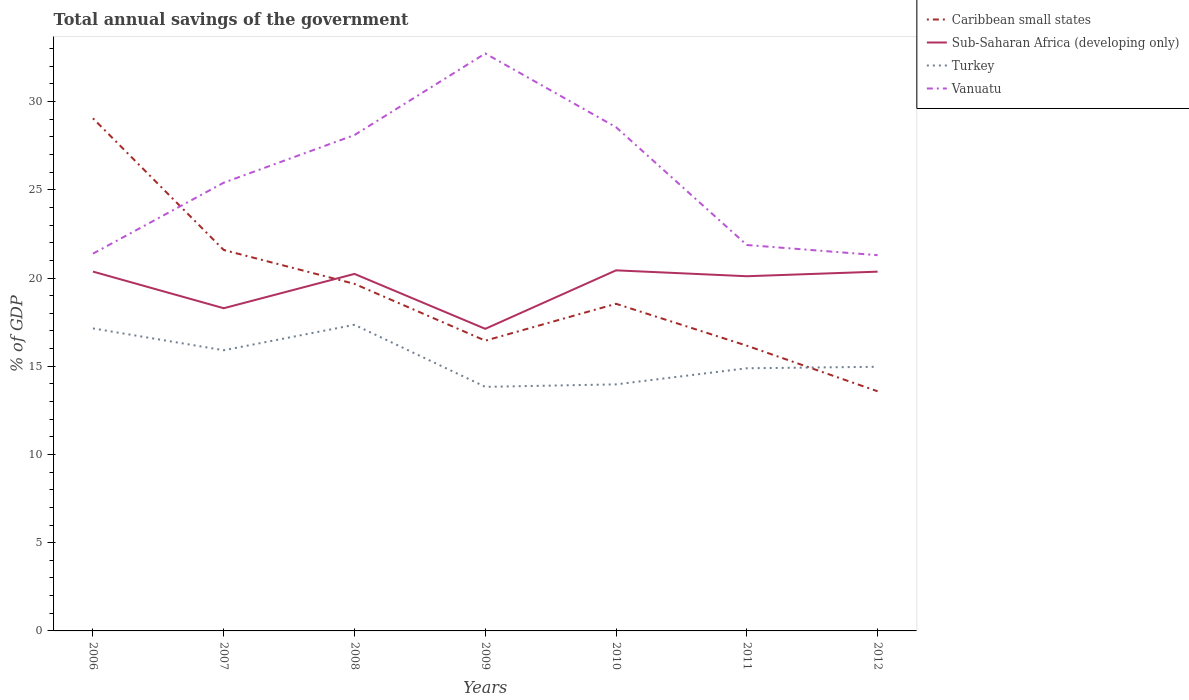How many different coloured lines are there?
Ensure brevity in your answer.  4. Across all years, what is the maximum total annual savings of the government in Sub-Saharan Africa (developing only)?
Make the answer very short. 17.12. What is the total total annual savings of the government in Caribbean small states in the graph?
Your answer should be compact. 6.09. What is the difference between the highest and the second highest total annual savings of the government in Sub-Saharan Africa (developing only)?
Provide a short and direct response. 3.31. What is the difference between the highest and the lowest total annual savings of the government in Vanuatu?
Make the answer very short. 3. Is the total annual savings of the government in Vanuatu strictly greater than the total annual savings of the government in Caribbean small states over the years?
Give a very brief answer. No. How many lines are there?
Offer a terse response. 4. How many years are there in the graph?
Give a very brief answer. 7. What is the difference between two consecutive major ticks on the Y-axis?
Keep it short and to the point. 5. How many legend labels are there?
Give a very brief answer. 4. What is the title of the graph?
Your response must be concise. Total annual savings of the government. Does "Bulgaria" appear as one of the legend labels in the graph?
Ensure brevity in your answer.  No. What is the label or title of the X-axis?
Ensure brevity in your answer.  Years. What is the label or title of the Y-axis?
Make the answer very short. % of GDP. What is the % of GDP in Caribbean small states in 2006?
Offer a very short reply. 29.05. What is the % of GDP in Sub-Saharan Africa (developing only) in 2006?
Your answer should be very brief. 20.36. What is the % of GDP of Turkey in 2006?
Your answer should be compact. 17.14. What is the % of GDP of Vanuatu in 2006?
Provide a succinct answer. 21.38. What is the % of GDP in Caribbean small states in 2007?
Provide a succinct answer. 21.59. What is the % of GDP in Sub-Saharan Africa (developing only) in 2007?
Make the answer very short. 18.29. What is the % of GDP of Turkey in 2007?
Offer a very short reply. 15.91. What is the % of GDP in Vanuatu in 2007?
Provide a short and direct response. 25.4. What is the % of GDP of Caribbean small states in 2008?
Your answer should be very brief. 19.67. What is the % of GDP of Sub-Saharan Africa (developing only) in 2008?
Your response must be concise. 20.23. What is the % of GDP in Turkey in 2008?
Offer a very short reply. 17.35. What is the % of GDP of Vanuatu in 2008?
Offer a very short reply. 28.1. What is the % of GDP of Caribbean small states in 2009?
Your answer should be compact. 16.45. What is the % of GDP in Sub-Saharan Africa (developing only) in 2009?
Your response must be concise. 17.12. What is the % of GDP in Turkey in 2009?
Offer a very short reply. 13.83. What is the % of GDP of Vanuatu in 2009?
Offer a very short reply. 32.73. What is the % of GDP of Caribbean small states in 2010?
Your answer should be compact. 18.54. What is the % of GDP of Sub-Saharan Africa (developing only) in 2010?
Provide a short and direct response. 20.44. What is the % of GDP in Turkey in 2010?
Provide a succinct answer. 13.97. What is the % of GDP of Vanuatu in 2010?
Your response must be concise. 28.55. What is the % of GDP of Caribbean small states in 2011?
Your response must be concise. 16.16. What is the % of GDP in Sub-Saharan Africa (developing only) in 2011?
Give a very brief answer. 20.1. What is the % of GDP of Turkey in 2011?
Provide a succinct answer. 14.89. What is the % of GDP of Vanuatu in 2011?
Your answer should be compact. 21.87. What is the % of GDP of Caribbean small states in 2012?
Provide a succinct answer. 13.58. What is the % of GDP in Sub-Saharan Africa (developing only) in 2012?
Make the answer very short. 20.36. What is the % of GDP in Turkey in 2012?
Your answer should be compact. 14.97. What is the % of GDP of Vanuatu in 2012?
Provide a succinct answer. 21.29. Across all years, what is the maximum % of GDP of Caribbean small states?
Your response must be concise. 29.05. Across all years, what is the maximum % of GDP of Sub-Saharan Africa (developing only)?
Your response must be concise. 20.44. Across all years, what is the maximum % of GDP in Turkey?
Your answer should be very brief. 17.35. Across all years, what is the maximum % of GDP of Vanuatu?
Provide a succinct answer. 32.73. Across all years, what is the minimum % of GDP in Caribbean small states?
Your response must be concise. 13.58. Across all years, what is the minimum % of GDP in Sub-Saharan Africa (developing only)?
Offer a terse response. 17.12. Across all years, what is the minimum % of GDP in Turkey?
Provide a short and direct response. 13.83. Across all years, what is the minimum % of GDP in Vanuatu?
Offer a very short reply. 21.29. What is the total % of GDP in Caribbean small states in the graph?
Keep it short and to the point. 135.04. What is the total % of GDP of Sub-Saharan Africa (developing only) in the graph?
Your response must be concise. 136.9. What is the total % of GDP in Turkey in the graph?
Your answer should be compact. 108.06. What is the total % of GDP in Vanuatu in the graph?
Your answer should be compact. 179.33. What is the difference between the % of GDP in Caribbean small states in 2006 and that in 2007?
Offer a very short reply. 7.46. What is the difference between the % of GDP of Sub-Saharan Africa (developing only) in 2006 and that in 2007?
Keep it short and to the point. 2.08. What is the difference between the % of GDP of Turkey in 2006 and that in 2007?
Offer a very short reply. 1.24. What is the difference between the % of GDP of Vanuatu in 2006 and that in 2007?
Your answer should be compact. -4.02. What is the difference between the % of GDP in Caribbean small states in 2006 and that in 2008?
Your response must be concise. 9.38. What is the difference between the % of GDP of Sub-Saharan Africa (developing only) in 2006 and that in 2008?
Make the answer very short. 0.13. What is the difference between the % of GDP in Turkey in 2006 and that in 2008?
Your answer should be compact. -0.21. What is the difference between the % of GDP of Vanuatu in 2006 and that in 2008?
Provide a short and direct response. -6.72. What is the difference between the % of GDP in Caribbean small states in 2006 and that in 2009?
Your answer should be very brief. 12.6. What is the difference between the % of GDP in Sub-Saharan Africa (developing only) in 2006 and that in 2009?
Keep it short and to the point. 3.24. What is the difference between the % of GDP of Turkey in 2006 and that in 2009?
Your answer should be compact. 3.31. What is the difference between the % of GDP in Vanuatu in 2006 and that in 2009?
Offer a very short reply. -11.35. What is the difference between the % of GDP in Caribbean small states in 2006 and that in 2010?
Your answer should be compact. 10.51. What is the difference between the % of GDP in Sub-Saharan Africa (developing only) in 2006 and that in 2010?
Offer a terse response. -0.07. What is the difference between the % of GDP of Turkey in 2006 and that in 2010?
Make the answer very short. 3.17. What is the difference between the % of GDP in Vanuatu in 2006 and that in 2010?
Offer a very short reply. -7.17. What is the difference between the % of GDP in Caribbean small states in 2006 and that in 2011?
Offer a terse response. 12.89. What is the difference between the % of GDP of Sub-Saharan Africa (developing only) in 2006 and that in 2011?
Offer a terse response. 0.26. What is the difference between the % of GDP in Turkey in 2006 and that in 2011?
Make the answer very short. 2.26. What is the difference between the % of GDP of Vanuatu in 2006 and that in 2011?
Your answer should be compact. -0.49. What is the difference between the % of GDP of Caribbean small states in 2006 and that in 2012?
Your answer should be compact. 15.47. What is the difference between the % of GDP of Sub-Saharan Africa (developing only) in 2006 and that in 2012?
Offer a very short reply. 0. What is the difference between the % of GDP in Turkey in 2006 and that in 2012?
Give a very brief answer. 2.17. What is the difference between the % of GDP of Vanuatu in 2006 and that in 2012?
Offer a terse response. 0.09. What is the difference between the % of GDP of Caribbean small states in 2007 and that in 2008?
Your answer should be very brief. 1.92. What is the difference between the % of GDP of Sub-Saharan Africa (developing only) in 2007 and that in 2008?
Give a very brief answer. -1.95. What is the difference between the % of GDP in Turkey in 2007 and that in 2008?
Keep it short and to the point. -1.44. What is the difference between the % of GDP in Vanuatu in 2007 and that in 2008?
Make the answer very short. -2.7. What is the difference between the % of GDP in Caribbean small states in 2007 and that in 2009?
Make the answer very short. 5.14. What is the difference between the % of GDP in Sub-Saharan Africa (developing only) in 2007 and that in 2009?
Give a very brief answer. 1.17. What is the difference between the % of GDP of Turkey in 2007 and that in 2009?
Give a very brief answer. 2.07. What is the difference between the % of GDP in Vanuatu in 2007 and that in 2009?
Keep it short and to the point. -7.32. What is the difference between the % of GDP in Caribbean small states in 2007 and that in 2010?
Keep it short and to the point. 3.05. What is the difference between the % of GDP in Sub-Saharan Africa (developing only) in 2007 and that in 2010?
Give a very brief answer. -2.15. What is the difference between the % of GDP of Turkey in 2007 and that in 2010?
Your answer should be very brief. 1.93. What is the difference between the % of GDP in Vanuatu in 2007 and that in 2010?
Your answer should be very brief. -3.14. What is the difference between the % of GDP of Caribbean small states in 2007 and that in 2011?
Your answer should be very brief. 5.42. What is the difference between the % of GDP in Sub-Saharan Africa (developing only) in 2007 and that in 2011?
Your answer should be very brief. -1.81. What is the difference between the % of GDP of Turkey in 2007 and that in 2011?
Make the answer very short. 1.02. What is the difference between the % of GDP in Vanuatu in 2007 and that in 2011?
Give a very brief answer. 3.53. What is the difference between the % of GDP of Caribbean small states in 2007 and that in 2012?
Your answer should be compact. 8.01. What is the difference between the % of GDP in Sub-Saharan Africa (developing only) in 2007 and that in 2012?
Your answer should be compact. -2.07. What is the difference between the % of GDP in Turkey in 2007 and that in 2012?
Offer a terse response. 0.94. What is the difference between the % of GDP in Vanuatu in 2007 and that in 2012?
Make the answer very short. 4.11. What is the difference between the % of GDP in Caribbean small states in 2008 and that in 2009?
Your answer should be compact. 3.22. What is the difference between the % of GDP in Sub-Saharan Africa (developing only) in 2008 and that in 2009?
Make the answer very short. 3.11. What is the difference between the % of GDP in Turkey in 2008 and that in 2009?
Offer a very short reply. 3.52. What is the difference between the % of GDP of Vanuatu in 2008 and that in 2009?
Ensure brevity in your answer.  -4.62. What is the difference between the % of GDP of Caribbean small states in 2008 and that in 2010?
Your response must be concise. 1.13. What is the difference between the % of GDP of Sub-Saharan Africa (developing only) in 2008 and that in 2010?
Offer a very short reply. -0.2. What is the difference between the % of GDP in Turkey in 2008 and that in 2010?
Your response must be concise. 3.38. What is the difference between the % of GDP in Vanuatu in 2008 and that in 2010?
Your answer should be very brief. -0.44. What is the difference between the % of GDP in Caribbean small states in 2008 and that in 2011?
Your answer should be compact. 3.5. What is the difference between the % of GDP in Sub-Saharan Africa (developing only) in 2008 and that in 2011?
Provide a short and direct response. 0.13. What is the difference between the % of GDP in Turkey in 2008 and that in 2011?
Your answer should be very brief. 2.46. What is the difference between the % of GDP in Vanuatu in 2008 and that in 2011?
Provide a succinct answer. 6.23. What is the difference between the % of GDP of Caribbean small states in 2008 and that in 2012?
Keep it short and to the point. 6.09. What is the difference between the % of GDP in Sub-Saharan Africa (developing only) in 2008 and that in 2012?
Provide a short and direct response. -0.13. What is the difference between the % of GDP of Turkey in 2008 and that in 2012?
Your answer should be compact. 2.38. What is the difference between the % of GDP in Vanuatu in 2008 and that in 2012?
Provide a short and direct response. 6.81. What is the difference between the % of GDP in Caribbean small states in 2009 and that in 2010?
Give a very brief answer. -2.09. What is the difference between the % of GDP of Sub-Saharan Africa (developing only) in 2009 and that in 2010?
Offer a very short reply. -3.31. What is the difference between the % of GDP in Turkey in 2009 and that in 2010?
Keep it short and to the point. -0.14. What is the difference between the % of GDP in Vanuatu in 2009 and that in 2010?
Provide a short and direct response. 4.18. What is the difference between the % of GDP in Caribbean small states in 2009 and that in 2011?
Your answer should be compact. 0.28. What is the difference between the % of GDP in Sub-Saharan Africa (developing only) in 2009 and that in 2011?
Your response must be concise. -2.98. What is the difference between the % of GDP in Turkey in 2009 and that in 2011?
Make the answer very short. -1.05. What is the difference between the % of GDP of Vanuatu in 2009 and that in 2011?
Make the answer very short. 10.85. What is the difference between the % of GDP of Caribbean small states in 2009 and that in 2012?
Offer a terse response. 2.87. What is the difference between the % of GDP of Sub-Saharan Africa (developing only) in 2009 and that in 2012?
Your response must be concise. -3.24. What is the difference between the % of GDP of Turkey in 2009 and that in 2012?
Give a very brief answer. -1.14. What is the difference between the % of GDP of Vanuatu in 2009 and that in 2012?
Give a very brief answer. 11.43. What is the difference between the % of GDP of Caribbean small states in 2010 and that in 2011?
Provide a short and direct response. 2.37. What is the difference between the % of GDP in Sub-Saharan Africa (developing only) in 2010 and that in 2011?
Give a very brief answer. 0.33. What is the difference between the % of GDP in Turkey in 2010 and that in 2011?
Offer a very short reply. -0.91. What is the difference between the % of GDP in Vanuatu in 2010 and that in 2011?
Your answer should be compact. 6.68. What is the difference between the % of GDP in Caribbean small states in 2010 and that in 2012?
Offer a very short reply. 4.96. What is the difference between the % of GDP in Sub-Saharan Africa (developing only) in 2010 and that in 2012?
Provide a succinct answer. 0.07. What is the difference between the % of GDP in Turkey in 2010 and that in 2012?
Your response must be concise. -1. What is the difference between the % of GDP of Vanuatu in 2010 and that in 2012?
Give a very brief answer. 7.25. What is the difference between the % of GDP in Caribbean small states in 2011 and that in 2012?
Your answer should be compact. 2.58. What is the difference between the % of GDP in Sub-Saharan Africa (developing only) in 2011 and that in 2012?
Offer a terse response. -0.26. What is the difference between the % of GDP of Turkey in 2011 and that in 2012?
Your answer should be very brief. -0.08. What is the difference between the % of GDP in Vanuatu in 2011 and that in 2012?
Provide a succinct answer. 0.58. What is the difference between the % of GDP of Caribbean small states in 2006 and the % of GDP of Sub-Saharan Africa (developing only) in 2007?
Your answer should be very brief. 10.76. What is the difference between the % of GDP of Caribbean small states in 2006 and the % of GDP of Turkey in 2007?
Make the answer very short. 13.14. What is the difference between the % of GDP in Caribbean small states in 2006 and the % of GDP in Vanuatu in 2007?
Your answer should be very brief. 3.65. What is the difference between the % of GDP of Sub-Saharan Africa (developing only) in 2006 and the % of GDP of Turkey in 2007?
Provide a succinct answer. 4.46. What is the difference between the % of GDP in Sub-Saharan Africa (developing only) in 2006 and the % of GDP in Vanuatu in 2007?
Make the answer very short. -5.04. What is the difference between the % of GDP of Turkey in 2006 and the % of GDP of Vanuatu in 2007?
Your response must be concise. -8.26. What is the difference between the % of GDP of Caribbean small states in 2006 and the % of GDP of Sub-Saharan Africa (developing only) in 2008?
Provide a short and direct response. 8.82. What is the difference between the % of GDP of Caribbean small states in 2006 and the % of GDP of Turkey in 2008?
Keep it short and to the point. 11.7. What is the difference between the % of GDP in Caribbean small states in 2006 and the % of GDP in Vanuatu in 2008?
Offer a terse response. 0.95. What is the difference between the % of GDP in Sub-Saharan Africa (developing only) in 2006 and the % of GDP in Turkey in 2008?
Offer a very short reply. 3.02. What is the difference between the % of GDP in Sub-Saharan Africa (developing only) in 2006 and the % of GDP in Vanuatu in 2008?
Offer a terse response. -7.74. What is the difference between the % of GDP of Turkey in 2006 and the % of GDP of Vanuatu in 2008?
Ensure brevity in your answer.  -10.96. What is the difference between the % of GDP of Caribbean small states in 2006 and the % of GDP of Sub-Saharan Africa (developing only) in 2009?
Make the answer very short. 11.93. What is the difference between the % of GDP in Caribbean small states in 2006 and the % of GDP in Turkey in 2009?
Keep it short and to the point. 15.22. What is the difference between the % of GDP in Caribbean small states in 2006 and the % of GDP in Vanuatu in 2009?
Provide a short and direct response. -3.68. What is the difference between the % of GDP of Sub-Saharan Africa (developing only) in 2006 and the % of GDP of Turkey in 2009?
Ensure brevity in your answer.  6.53. What is the difference between the % of GDP of Sub-Saharan Africa (developing only) in 2006 and the % of GDP of Vanuatu in 2009?
Your response must be concise. -12.36. What is the difference between the % of GDP of Turkey in 2006 and the % of GDP of Vanuatu in 2009?
Provide a succinct answer. -15.58. What is the difference between the % of GDP of Caribbean small states in 2006 and the % of GDP of Sub-Saharan Africa (developing only) in 2010?
Provide a short and direct response. 8.62. What is the difference between the % of GDP of Caribbean small states in 2006 and the % of GDP of Turkey in 2010?
Offer a terse response. 15.08. What is the difference between the % of GDP in Caribbean small states in 2006 and the % of GDP in Vanuatu in 2010?
Provide a succinct answer. 0.5. What is the difference between the % of GDP of Sub-Saharan Africa (developing only) in 2006 and the % of GDP of Turkey in 2010?
Give a very brief answer. 6.39. What is the difference between the % of GDP of Sub-Saharan Africa (developing only) in 2006 and the % of GDP of Vanuatu in 2010?
Your answer should be very brief. -8.18. What is the difference between the % of GDP of Turkey in 2006 and the % of GDP of Vanuatu in 2010?
Make the answer very short. -11.4. What is the difference between the % of GDP in Caribbean small states in 2006 and the % of GDP in Sub-Saharan Africa (developing only) in 2011?
Give a very brief answer. 8.95. What is the difference between the % of GDP of Caribbean small states in 2006 and the % of GDP of Turkey in 2011?
Provide a short and direct response. 14.17. What is the difference between the % of GDP of Caribbean small states in 2006 and the % of GDP of Vanuatu in 2011?
Offer a very short reply. 7.18. What is the difference between the % of GDP in Sub-Saharan Africa (developing only) in 2006 and the % of GDP in Turkey in 2011?
Provide a short and direct response. 5.48. What is the difference between the % of GDP in Sub-Saharan Africa (developing only) in 2006 and the % of GDP in Vanuatu in 2011?
Offer a terse response. -1.51. What is the difference between the % of GDP of Turkey in 2006 and the % of GDP of Vanuatu in 2011?
Make the answer very short. -4.73. What is the difference between the % of GDP in Caribbean small states in 2006 and the % of GDP in Sub-Saharan Africa (developing only) in 2012?
Provide a succinct answer. 8.69. What is the difference between the % of GDP in Caribbean small states in 2006 and the % of GDP in Turkey in 2012?
Provide a short and direct response. 14.08. What is the difference between the % of GDP of Caribbean small states in 2006 and the % of GDP of Vanuatu in 2012?
Your response must be concise. 7.76. What is the difference between the % of GDP in Sub-Saharan Africa (developing only) in 2006 and the % of GDP in Turkey in 2012?
Your answer should be compact. 5.39. What is the difference between the % of GDP in Sub-Saharan Africa (developing only) in 2006 and the % of GDP in Vanuatu in 2012?
Provide a short and direct response. -0.93. What is the difference between the % of GDP in Turkey in 2006 and the % of GDP in Vanuatu in 2012?
Your answer should be compact. -4.15. What is the difference between the % of GDP of Caribbean small states in 2007 and the % of GDP of Sub-Saharan Africa (developing only) in 2008?
Offer a very short reply. 1.35. What is the difference between the % of GDP of Caribbean small states in 2007 and the % of GDP of Turkey in 2008?
Provide a short and direct response. 4.24. What is the difference between the % of GDP in Caribbean small states in 2007 and the % of GDP in Vanuatu in 2008?
Provide a succinct answer. -6.51. What is the difference between the % of GDP in Sub-Saharan Africa (developing only) in 2007 and the % of GDP in Turkey in 2008?
Offer a terse response. 0.94. What is the difference between the % of GDP in Sub-Saharan Africa (developing only) in 2007 and the % of GDP in Vanuatu in 2008?
Your response must be concise. -9.81. What is the difference between the % of GDP of Turkey in 2007 and the % of GDP of Vanuatu in 2008?
Provide a short and direct response. -12.2. What is the difference between the % of GDP of Caribbean small states in 2007 and the % of GDP of Sub-Saharan Africa (developing only) in 2009?
Ensure brevity in your answer.  4.47. What is the difference between the % of GDP of Caribbean small states in 2007 and the % of GDP of Turkey in 2009?
Keep it short and to the point. 7.76. What is the difference between the % of GDP in Caribbean small states in 2007 and the % of GDP in Vanuatu in 2009?
Provide a short and direct response. -11.14. What is the difference between the % of GDP of Sub-Saharan Africa (developing only) in 2007 and the % of GDP of Turkey in 2009?
Your response must be concise. 4.46. What is the difference between the % of GDP in Sub-Saharan Africa (developing only) in 2007 and the % of GDP in Vanuatu in 2009?
Ensure brevity in your answer.  -14.44. What is the difference between the % of GDP in Turkey in 2007 and the % of GDP in Vanuatu in 2009?
Provide a succinct answer. -16.82. What is the difference between the % of GDP in Caribbean small states in 2007 and the % of GDP in Sub-Saharan Africa (developing only) in 2010?
Offer a very short reply. 1.15. What is the difference between the % of GDP in Caribbean small states in 2007 and the % of GDP in Turkey in 2010?
Your answer should be compact. 7.62. What is the difference between the % of GDP in Caribbean small states in 2007 and the % of GDP in Vanuatu in 2010?
Offer a very short reply. -6.96. What is the difference between the % of GDP of Sub-Saharan Africa (developing only) in 2007 and the % of GDP of Turkey in 2010?
Ensure brevity in your answer.  4.32. What is the difference between the % of GDP in Sub-Saharan Africa (developing only) in 2007 and the % of GDP in Vanuatu in 2010?
Make the answer very short. -10.26. What is the difference between the % of GDP in Turkey in 2007 and the % of GDP in Vanuatu in 2010?
Offer a terse response. -12.64. What is the difference between the % of GDP of Caribbean small states in 2007 and the % of GDP of Sub-Saharan Africa (developing only) in 2011?
Offer a very short reply. 1.49. What is the difference between the % of GDP in Caribbean small states in 2007 and the % of GDP in Turkey in 2011?
Provide a succinct answer. 6.7. What is the difference between the % of GDP in Caribbean small states in 2007 and the % of GDP in Vanuatu in 2011?
Your answer should be compact. -0.28. What is the difference between the % of GDP in Sub-Saharan Africa (developing only) in 2007 and the % of GDP in Turkey in 2011?
Give a very brief answer. 3.4. What is the difference between the % of GDP of Sub-Saharan Africa (developing only) in 2007 and the % of GDP of Vanuatu in 2011?
Provide a succinct answer. -3.58. What is the difference between the % of GDP of Turkey in 2007 and the % of GDP of Vanuatu in 2011?
Provide a short and direct response. -5.96. What is the difference between the % of GDP in Caribbean small states in 2007 and the % of GDP in Sub-Saharan Africa (developing only) in 2012?
Your response must be concise. 1.23. What is the difference between the % of GDP of Caribbean small states in 2007 and the % of GDP of Turkey in 2012?
Your answer should be compact. 6.62. What is the difference between the % of GDP of Caribbean small states in 2007 and the % of GDP of Vanuatu in 2012?
Provide a succinct answer. 0.29. What is the difference between the % of GDP in Sub-Saharan Africa (developing only) in 2007 and the % of GDP in Turkey in 2012?
Provide a succinct answer. 3.32. What is the difference between the % of GDP in Sub-Saharan Africa (developing only) in 2007 and the % of GDP in Vanuatu in 2012?
Ensure brevity in your answer.  -3.01. What is the difference between the % of GDP of Turkey in 2007 and the % of GDP of Vanuatu in 2012?
Your answer should be compact. -5.39. What is the difference between the % of GDP of Caribbean small states in 2008 and the % of GDP of Sub-Saharan Africa (developing only) in 2009?
Give a very brief answer. 2.55. What is the difference between the % of GDP in Caribbean small states in 2008 and the % of GDP in Turkey in 2009?
Your response must be concise. 5.84. What is the difference between the % of GDP in Caribbean small states in 2008 and the % of GDP in Vanuatu in 2009?
Give a very brief answer. -13.06. What is the difference between the % of GDP in Sub-Saharan Africa (developing only) in 2008 and the % of GDP in Turkey in 2009?
Offer a terse response. 6.4. What is the difference between the % of GDP of Sub-Saharan Africa (developing only) in 2008 and the % of GDP of Vanuatu in 2009?
Provide a succinct answer. -12.49. What is the difference between the % of GDP in Turkey in 2008 and the % of GDP in Vanuatu in 2009?
Provide a succinct answer. -15.38. What is the difference between the % of GDP of Caribbean small states in 2008 and the % of GDP of Sub-Saharan Africa (developing only) in 2010?
Keep it short and to the point. -0.77. What is the difference between the % of GDP of Caribbean small states in 2008 and the % of GDP of Turkey in 2010?
Offer a very short reply. 5.7. What is the difference between the % of GDP of Caribbean small states in 2008 and the % of GDP of Vanuatu in 2010?
Give a very brief answer. -8.88. What is the difference between the % of GDP of Sub-Saharan Africa (developing only) in 2008 and the % of GDP of Turkey in 2010?
Provide a short and direct response. 6.26. What is the difference between the % of GDP of Sub-Saharan Africa (developing only) in 2008 and the % of GDP of Vanuatu in 2010?
Offer a terse response. -8.31. What is the difference between the % of GDP in Turkey in 2008 and the % of GDP in Vanuatu in 2010?
Provide a short and direct response. -11.2. What is the difference between the % of GDP of Caribbean small states in 2008 and the % of GDP of Sub-Saharan Africa (developing only) in 2011?
Make the answer very short. -0.43. What is the difference between the % of GDP of Caribbean small states in 2008 and the % of GDP of Turkey in 2011?
Give a very brief answer. 4.78. What is the difference between the % of GDP in Caribbean small states in 2008 and the % of GDP in Vanuatu in 2011?
Your answer should be compact. -2.2. What is the difference between the % of GDP in Sub-Saharan Africa (developing only) in 2008 and the % of GDP in Turkey in 2011?
Your response must be concise. 5.35. What is the difference between the % of GDP in Sub-Saharan Africa (developing only) in 2008 and the % of GDP in Vanuatu in 2011?
Provide a short and direct response. -1.64. What is the difference between the % of GDP of Turkey in 2008 and the % of GDP of Vanuatu in 2011?
Your answer should be compact. -4.52. What is the difference between the % of GDP in Caribbean small states in 2008 and the % of GDP in Sub-Saharan Africa (developing only) in 2012?
Provide a succinct answer. -0.69. What is the difference between the % of GDP in Caribbean small states in 2008 and the % of GDP in Turkey in 2012?
Offer a very short reply. 4.7. What is the difference between the % of GDP in Caribbean small states in 2008 and the % of GDP in Vanuatu in 2012?
Give a very brief answer. -1.63. What is the difference between the % of GDP of Sub-Saharan Africa (developing only) in 2008 and the % of GDP of Turkey in 2012?
Offer a very short reply. 5.26. What is the difference between the % of GDP in Sub-Saharan Africa (developing only) in 2008 and the % of GDP in Vanuatu in 2012?
Give a very brief answer. -1.06. What is the difference between the % of GDP of Turkey in 2008 and the % of GDP of Vanuatu in 2012?
Ensure brevity in your answer.  -3.94. What is the difference between the % of GDP of Caribbean small states in 2009 and the % of GDP of Sub-Saharan Africa (developing only) in 2010?
Offer a very short reply. -3.99. What is the difference between the % of GDP in Caribbean small states in 2009 and the % of GDP in Turkey in 2010?
Your response must be concise. 2.48. What is the difference between the % of GDP of Caribbean small states in 2009 and the % of GDP of Vanuatu in 2010?
Your response must be concise. -12.1. What is the difference between the % of GDP of Sub-Saharan Africa (developing only) in 2009 and the % of GDP of Turkey in 2010?
Keep it short and to the point. 3.15. What is the difference between the % of GDP in Sub-Saharan Africa (developing only) in 2009 and the % of GDP in Vanuatu in 2010?
Offer a very short reply. -11.43. What is the difference between the % of GDP of Turkey in 2009 and the % of GDP of Vanuatu in 2010?
Give a very brief answer. -14.71. What is the difference between the % of GDP of Caribbean small states in 2009 and the % of GDP of Sub-Saharan Africa (developing only) in 2011?
Your response must be concise. -3.65. What is the difference between the % of GDP of Caribbean small states in 2009 and the % of GDP of Turkey in 2011?
Provide a succinct answer. 1.56. What is the difference between the % of GDP in Caribbean small states in 2009 and the % of GDP in Vanuatu in 2011?
Provide a succinct answer. -5.42. What is the difference between the % of GDP of Sub-Saharan Africa (developing only) in 2009 and the % of GDP of Turkey in 2011?
Provide a succinct answer. 2.24. What is the difference between the % of GDP in Sub-Saharan Africa (developing only) in 2009 and the % of GDP in Vanuatu in 2011?
Your response must be concise. -4.75. What is the difference between the % of GDP in Turkey in 2009 and the % of GDP in Vanuatu in 2011?
Give a very brief answer. -8.04. What is the difference between the % of GDP in Caribbean small states in 2009 and the % of GDP in Sub-Saharan Africa (developing only) in 2012?
Offer a terse response. -3.91. What is the difference between the % of GDP of Caribbean small states in 2009 and the % of GDP of Turkey in 2012?
Offer a very short reply. 1.48. What is the difference between the % of GDP in Caribbean small states in 2009 and the % of GDP in Vanuatu in 2012?
Provide a succinct answer. -4.84. What is the difference between the % of GDP in Sub-Saharan Africa (developing only) in 2009 and the % of GDP in Turkey in 2012?
Provide a short and direct response. 2.15. What is the difference between the % of GDP in Sub-Saharan Africa (developing only) in 2009 and the % of GDP in Vanuatu in 2012?
Your response must be concise. -4.17. What is the difference between the % of GDP of Turkey in 2009 and the % of GDP of Vanuatu in 2012?
Give a very brief answer. -7.46. What is the difference between the % of GDP of Caribbean small states in 2010 and the % of GDP of Sub-Saharan Africa (developing only) in 2011?
Provide a short and direct response. -1.56. What is the difference between the % of GDP in Caribbean small states in 2010 and the % of GDP in Turkey in 2011?
Offer a very short reply. 3.65. What is the difference between the % of GDP of Caribbean small states in 2010 and the % of GDP of Vanuatu in 2011?
Your answer should be very brief. -3.33. What is the difference between the % of GDP of Sub-Saharan Africa (developing only) in 2010 and the % of GDP of Turkey in 2011?
Provide a succinct answer. 5.55. What is the difference between the % of GDP of Sub-Saharan Africa (developing only) in 2010 and the % of GDP of Vanuatu in 2011?
Your answer should be compact. -1.44. What is the difference between the % of GDP in Turkey in 2010 and the % of GDP in Vanuatu in 2011?
Provide a succinct answer. -7.9. What is the difference between the % of GDP in Caribbean small states in 2010 and the % of GDP in Sub-Saharan Africa (developing only) in 2012?
Offer a very short reply. -1.82. What is the difference between the % of GDP in Caribbean small states in 2010 and the % of GDP in Turkey in 2012?
Keep it short and to the point. 3.57. What is the difference between the % of GDP of Caribbean small states in 2010 and the % of GDP of Vanuatu in 2012?
Offer a terse response. -2.75. What is the difference between the % of GDP of Sub-Saharan Africa (developing only) in 2010 and the % of GDP of Turkey in 2012?
Your response must be concise. 5.47. What is the difference between the % of GDP of Sub-Saharan Africa (developing only) in 2010 and the % of GDP of Vanuatu in 2012?
Offer a very short reply. -0.86. What is the difference between the % of GDP of Turkey in 2010 and the % of GDP of Vanuatu in 2012?
Provide a succinct answer. -7.32. What is the difference between the % of GDP in Caribbean small states in 2011 and the % of GDP in Sub-Saharan Africa (developing only) in 2012?
Your answer should be very brief. -4.2. What is the difference between the % of GDP of Caribbean small states in 2011 and the % of GDP of Turkey in 2012?
Offer a terse response. 1.19. What is the difference between the % of GDP in Caribbean small states in 2011 and the % of GDP in Vanuatu in 2012?
Provide a succinct answer. -5.13. What is the difference between the % of GDP of Sub-Saharan Africa (developing only) in 2011 and the % of GDP of Turkey in 2012?
Provide a short and direct response. 5.13. What is the difference between the % of GDP of Sub-Saharan Africa (developing only) in 2011 and the % of GDP of Vanuatu in 2012?
Offer a terse response. -1.19. What is the difference between the % of GDP of Turkey in 2011 and the % of GDP of Vanuatu in 2012?
Give a very brief answer. -6.41. What is the average % of GDP in Caribbean small states per year?
Provide a short and direct response. 19.29. What is the average % of GDP in Sub-Saharan Africa (developing only) per year?
Offer a very short reply. 19.56. What is the average % of GDP in Turkey per year?
Your response must be concise. 15.44. What is the average % of GDP of Vanuatu per year?
Ensure brevity in your answer.  25.62. In the year 2006, what is the difference between the % of GDP in Caribbean small states and % of GDP in Sub-Saharan Africa (developing only)?
Ensure brevity in your answer.  8.69. In the year 2006, what is the difference between the % of GDP in Caribbean small states and % of GDP in Turkey?
Provide a short and direct response. 11.91. In the year 2006, what is the difference between the % of GDP of Caribbean small states and % of GDP of Vanuatu?
Provide a short and direct response. 7.67. In the year 2006, what is the difference between the % of GDP in Sub-Saharan Africa (developing only) and % of GDP in Turkey?
Ensure brevity in your answer.  3.22. In the year 2006, what is the difference between the % of GDP of Sub-Saharan Africa (developing only) and % of GDP of Vanuatu?
Your answer should be very brief. -1.02. In the year 2006, what is the difference between the % of GDP of Turkey and % of GDP of Vanuatu?
Your answer should be very brief. -4.24. In the year 2007, what is the difference between the % of GDP in Caribbean small states and % of GDP in Sub-Saharan Africa (developing only)?
Provide a short and direct response. 3.3. In the year 2007, what is the difference between the % of GDP of Caribbean small states and % of GDP of Turkey?
Offer a very short reply. 5.68. In the year 2007, what is the difference between the % of GDP of Caribbean small states and % of GDP of Vanuatu?
Keep it short and to the point. -3.82. In the year 2007, what is the difference between the % of GDP of Sub-Saharan Africa (developing only) and % of GDP of Turkey?
Your answer should be very brief. 2.38. In the year 2007, what is the difference between the % of GDP of Sub-Saharan Africa (developing only) and % of GDP of Vanuatu?
Make the answer very short. -7.12. In the year 2007, what is the difference between the % of GDP of Turkey and % of GDP of Vanuatu?
Your response must be concise. -9.5. In the year 2008, what is the difference between the % of GDP of Caribbean small states and % of GDP of Sub-Saharan Africa (developing only)?
Your answer should be compact. -0.56. In the year 2008, what is the difference between the % of GDP of Caribbean small states and % of GDP of Turkey?
Give a very brief answer. 2.32. In the year 2008, what is the difference between the % of GDP of Caribbean small states and % of GDP of Vanuatu?
Your answer should be very brief. -8.43. In the year 2008, what is the difference between the % of GDP in Sub-Saharan Africa (developing only) and % of GDP in Turkey?
Your response must be concise. 2.88. In the year 2008, what is the difference between the % of GDP of Sub-Saharan Africa (developing only) and % of GDP of Vanuatu?
Keep it short and to the point. -7.87. In the year 2008, what is the difference between the % of GDP in Turkey and % of GDP in Vanuatu?
Ensure brevity in your answer.  -10.75. In the year 2009, what is the difference between the % of GDP in Caribbean small states and % of GDP in Sub-Saharan Africa (developing only)?
Provide a short and direct response. -0.67. In the year 2009, what is the difference between the % of GDP in Caribbean small states and % of GDP in Turkey?
Your answer should be very brief. 2.62. In the year 2009, what is the difference between the % of GDP in Caribbean small states and % of GDP in Vanuatu?
Offer a terse response. -16.28. In the year 2009, what is the difference between the % of GDP of Sub-Saharan Africa (developing only) and % of GDP of Turkey?
Provide a short and direct response. 3.29. In the year 2009, what is the difference between the % of GDP in Sub-Saharan Africa (developing only) and % of GDP in Vanuatu?
Give a very brief answer. -15.61. In the year 2009, what is the difference between the % of GDP in Turkey and % of GDP in Vanuatu?
Your answer should be compact. -18.89. In the year 2010, what is the difference between the % of GDP in Caribbean small states and % of GDP in Sub-Saharan Africa (developing only)?
Your answer should be very brief. -1.9. In the year 2010, what is the difference between the % of GDP of Caribbean small states and % of GDP of Turkey?
Provide a succinct answer. 4.57. In the year 2010, what is the difference between the % of GDP of Caribbean small states and % of GDP of Vanuatu?
Make the answer very short. -10.01. In the year 2010, what is the difference between the % of GDP in Sub-Saharan Africa (developing only) and % of GDP in Turkey?
Ensure brevity in your answer.  6.46. In the year 2010, what is the difference between the % of GDP of Sub-Saharan Africa (developing only) and % of GDP of Vanuatu?
Offer a very short reply. -8.11. In the year 2010, what is the difference between the % of GDP in Turkey and % of GDP in Vanuatu?
Make the answer very short. -14.57. In the year 2011, what is the difference between the % of GDP of Caribbean small states and % of GDP of Sub-Saharan Africa (developing only)?
Offer a very short reply. -3.94. In the year 2011, what is the difference between the % of GDP of Caribbean small states and % of GDP of Turkey?
Give a very brief answer. 1.28. In the year 2011, what is the difference between the % of GDP of Caribbean small states and % of GDP of Vanuatu?
Ensure brevity in your answer.  -5.71. In the year 2011, what is the difference between the % of GDP in Sub-Saharan Africa (developing only) and % of GDP in Turkey?
Make the answer very short. 5.22. In the year 2011, what is the difference between the % of GDP in Sub-Saharan Africa (developing only) and % of GDP in Vanuatu?
Provide a succinct answer. -1.77. In the year 2011, what is the difference between the % of GDP of Turkey and % of GDP of Vanuatu?
Provide a short and direct response. -6.99. In the year 2012, what is the difference between the % of GDP of Caribbean small states and % of GDP of Sub-Saharan Africa (developing only)?
Offer a terse response. -6.78. In the year 2012, what is the difference between the % of GDP in Caribbean small states and % of GDP in Turkey?
Your response must be concise. -1.39. In the year 2012, what is the difference between the % of GDP in Caribbean small states and % of GDP in Vanuatu?
Your answer should be compact. -7.71. In the year 2012, what is the difference between the % of GDP in Sub-Saharan Africa (developing only) and % of GDP in Turkey?
Offer a terse response. 5.39. In the year 2012, what is the difference between the % of GDP in Sub-Saharan Africa (developing only) and % of GDP in Vanuatu?
Your response must be concise. -0.93. In the year 2012, what is the difference between the % of GDP in Turkey and % of GDP in Vanuatu?
Provide a short and direct response. -6.32. What is the ratio of the % of GDP in Caribbean small states in 2006 to that in 2007?
Offer a terse response. 1.35. What is the ratio of the % of GDP of Sub-Saharan Africa (developing only) in 2006 to that in 2007?
Provide a succinct answer. 1.11. What is the ratio of the % of GDP of Turkey in 2006 to that in 2007?
Your answer should be very brief. 1.08. What is the ratio of the % of GDP of Vanuatu in 2006 to that in 2007?
Provide a short and direct response. 0.84. What is the ratio of the % of GDP of Caribbean small states in 2006 to that in 2008?
Your response must be concise. 1.48. What is the ratio of the % of GDP of Turkey in 2006 to that in 2008?
Make the answer very short. 0.99. What is the ratio of the % of GDP of Vanuatu in 2006 to that in 2008?
Keep it short and to the point. 0.76. What is the ratio of the % of GDP in Caribbean small states in 2006 to that in 2009?
Provide a succinct answer. 1.77. What is the ratio of the % of GDP of Sub-Saharan Africa (developing only) in 2006 to that in 2009?
Keep it short and to the point. 1.19. What is the ratio of the % of GDP of Turkey in 2006 to that in 2009?
Offer a very short reply. 1.24. What is the ratio of the % of GDP of Vanuatu in 2006 to that in 2009?
Provide a short and direct response. 0.65. What is the ratio of the % of GDP in Caribbean small states in 2006 to that in 2010?
Keep it short and to the point. 1.57. What is the ratio of the % of GDP in Sub-Saharan Africa (developing only) in 2006 to that in 2010?
Offer a terse response. 1. What is the ratio of the % of GDP of Turkey in 2006 to that in 2010?
Give a very brief answer. 1.23. What is the ratio of the % of GDP in Vanuatu in 2006 to that in 2010?
Give a very brief answer. 0.75. What is the ratio of the % of GDP of Caribbean small states in 2006 to that in 2011?
Keep it short and to the point. 1.8. What is the ratio of the % of GDP in Sub-Saharan Africa (developing only) in 2006 to that in 2011?
Your answer should be compact. 1.01. What is the ratio of the % of GDP in Turkey in 2006 to that in 2011?
Ensure brevity in your answer.  1.15. What is the ratio of the % of GDP in Vanuatu in 2006 to that in 2011?
Keep it short and to the point. 0.98. What is the ratio of the % of GDP in Caribbean small states in 2006 to that in 2012?
Make the answer very short. 2.14. What is the ratio of the % of GDP in Turkey in 2006 to that in 2012?
Give a very brief answer. 1.15. What is the ratio of the % of GDP of Vanuatu in 2006 to that in 2012?
Your answer should be compact. 1. What is the ratio of the % of GDP in Caribbean small states in 2007 to that in 2008?
Your answer should be compact. 1.1. What is the ratio of the % of GDP of Sub-Saharan Africa (developing only) in 2007 to that in 2008?
Give a very brief answer. 0.9. What is the ratio of the % of GDP of Turkey in 2007 to that in 2008?
Keep it short and to the point. 0.92. What is the ratio of the % of GDP of Vanuatu in 2007 to that in 2008?
Your response must be concise. 0.9. What is the ratio of the % of GDP of Caribbean small states in 2007 to that in 2009?
Ensure brevity in your answer.  1.31. What is the ratio of the % of GDP of Sub-Saharan Africa (developing only) in 2007 to that in 2009?
Your response must be concise. 1.07. What is the ratio of the % of GDP in Turkey in 2007 to that in 2009?
Provide a short and direct response. 1.15. What is the ratio of the % of GDP of Vanuatu in 2007 to that in 2009?
Your answer should be compact. 0.78. What is the ratio of the % of GDP of Caribbean small states in 2007 to that in 2010?
Make the answer very short. 1.16. What is the ratio of the % of GDP of Sub-Saharan Africa (developing only) in 2007 to that in 2010?
Ensure brevity in your answer.  0.89. What is the ratio of the % of GDP of Turkey in 2007 to that in 2010?
Provide a succinct answer. 1.14. What is the ratio of the % of GDP in Vanuatu in 2007 to that in 2010?
Give a very brief answer. 0.89. What is the ratio of the % of GDP in Caribbean small states in 2007 to that in 2011?
Keep it short and to the point. 1.34. What is the ratio of the % of GDP in Sub-Saharan Africa (developing only) in 2007 to that in 2011?
Ensure brevity in your answer.  0.91. What is the ratio of the % of GDP in Turkey in 2007 to that in 2011?
Your answer should be very brief. 1.07. What is the ratio of the % of GDP of Vanuatu in 2007 to that in 2011?
Provide a succinct answer. 1.16. What is the ratio of the % of GDP in Caribbean small states in 2007 to that in 2012?
Your answer should be very brief. 1.59. What is the ratio of the % of GDP in Sub-Saharan Africa (developing only) in 2007 to that in 2012?
Give a very brief answer. 0.9. What is the ratio of the % of GDP in Turkey in 2007 to that in 2012?
Your answer should be compact. 1.06. What is the ratio of the % of GDP of Vanuatu in 2007 to that in 2012?
Keep it short and to the point. 1.19. What is the ratio of the % of GDP of Caribbean small states in 2008 to that in 2009?
Your response must be concise. 1.2. What is the ratio of the % of GDP of Sub-Saharan Africa (developing only) in 2008 to that in 2009?
Offer a very short reply. 1.18. What is the ratio of the % of GDP of Turkey in 2008 to that in 2009?
Your answer should be very brief. 1.25. What is the ratio of the % of GDP in Vanuatu in 2008 to that in 2009?
Your response must be concise. 0.86. What is the ratio of the % of GDP in Caribbean small states in 2008 to that in 2010?
Your response must be concise. 1.06. What is the ratio of the % of GDP in Turkey in 2008 to that in 2010?
Provide a succinct answer. 1.24. What is the ratio of the % of GDP in Vanuatu in 2008 to that in 2010?
Offer a terse response. 0.98. What is the ratio of the % of GDP of Caribbean small states in 2008 to that in 2011?
Provide a short and direct response. 1.22. What is the ratio of the % of GDP of Sub-Saharan Africa (developing only) in 2008 to that in 2011?
Offer a very short reply. 1.01. What is the ratio of the % of GDP of Turkey in 2008 to that in 2011?
Offer a very short reply. 1.17. What is the ratio of the % of GDP in Vanuatu in 2008 to that in 2011?
Ensure brevity in your answer.  1.28. What is the ratio of the % of GDP of Caribbean small states in 2008 to that in 2012?
Your answer should be very brief. 1.45. What is the ratio of the % of GDP in Sub-Saharan Africa (developing only) in 2008 to that in 2012?
Provide a short and direct response. 0.99. What is the ratio of the % of GDP of Turkey in 2008 to that in 2012?
Offer a terse response. 1.16. What is the ratio of the % of GDP of Vanuatu in 2008 to that in 2012?
Your response must be concise. 1.32. What is the ratio of the % of GDP in Caribbean small states in 2009 to that in 2010?
Keep it short and to the point. 0.89. What is the ratio of the % of GDP in Sub-Saharan Africa (developing only) in 2009 to that in 2010?
Ensure brevity in your answer.  0.84. What is the ratio of the % of GDP of Vanuatu in 2009 to that in 2010?
Give a very brief answer. 1.15. What is the ratio of the % of GDP in Caribbean small states in 2009 to that in 2011?
Offer a very short reply. 1.02. What is the ratio of the % of GDP of Sub-Saharan Africa (developing only) in 2009 to that in 2011?
Ensure brevity in your answer.  0.85. What is the ratio of the % of GDP of Turkey in 2009 to that in 2011?
Keep it short and to the point. 0.93. What is the ratio of the % of GDP in Vanuatu in 2009 to that in 2011?
Your answer should be compact. 1.5. What is the ratio of the % of GDP in Caribbean small states in 2009 to that in 2012?
Ensure brevity in your answer.  1.21. What is the ratio of the % of GDP in Sub-Saharan Africa (developing only) in 2009 to that in 2012?
Ensure brevity in your answer.  0.84. What is the ratio of the % of GDP of Turkey in 2009 to that in 2012?
Ensure brevity in your answer.  0.92. What is the ratio of the % of GDP of Vanuatu in 2009 to that in 2012?
Your answer should be compact. 1.54. What is the ratio of the % of GDP in Caribbean small states in 2010 to that in 2011?
Keep it short and to the point. 1.15. What is the ratio of the % of GDP in Sub-Saharan Africa (developing only) in 2010 to that in 2011?
Provide a succinct answer. 1.02. What is the ratio of the % of GDP of Turkey in 2010 to that in 2011?
Your answer should be compact. 0.94. What is the ratio of the % of GDP of Vanuatu in 2010 to that in 2011?
Your response must be concise. 1.31. What is the ratio of the % of GDP of Caribbean small states in 2010 to that in 2012?
Offer a terse response. 1.37. What is the ratio of the % of GDP in Sub-Saharan Africa (developing only) in 2010 to that in 2012?
Offer a very short reply. 1. What is the ratio of the % of GDP in Turkey in 2010 to that in 2012?
Provide a succinct answer. 0.93. What is the ratio of the % of GDP of Vanuatu in 2010 to that in 2012?
Provide a short and direct response. 1.34. What is the ratio of the % of GDP in Caribbean small states in 2011 to that in 2012?
Offer a very short reply. 1.19. What is the ratio of the % of GDP in Sub-Saharan Africa (developing only) in 2011 to that in 2012?
Offer a very short reply. 0.99. What is the ratio of the % of GDP in Turkey in 2011 to that in 2012?
Your answer should be very brief. 0.99. What is the ratio of the % of GDP of Vanuatu in 2011 to that in 2012?
Keep it short and to the point. 1.03. What is the difference between the highest and the second highest % of GDP in Caribbean small states?
Provide a succinct answer. 7.46. What is the difference between the highest and the second highest % of GDP of Sub-Saharan Africa (developing only)?
Ensure brevity in your answer.  0.07. What is the difference between the highest and the second highest % of GDP of Turkey?
Ensure brevity in your answer.  0.21. What is the difference between the highest and the second highest % of GDP in Vanuatu?
Your response must be concise. 4.18. What is the difference between the highest and the lowest % of GDP in Caribbean small states?
Provide a short and direct response. 15.47. What is the difference between the highest and the lowest % of GDP of Sub-Saharan Africa (developing only)?
Ensure brevity in your answer.  3.31. What is the difference between the highest and the lowest % of GDP of Turkey?
Ensure brevity in your answer.  3.52. What is the difference between the highest and the lowest % of GDP in Vanuatu?
Give a very brief answer. 11.43. 